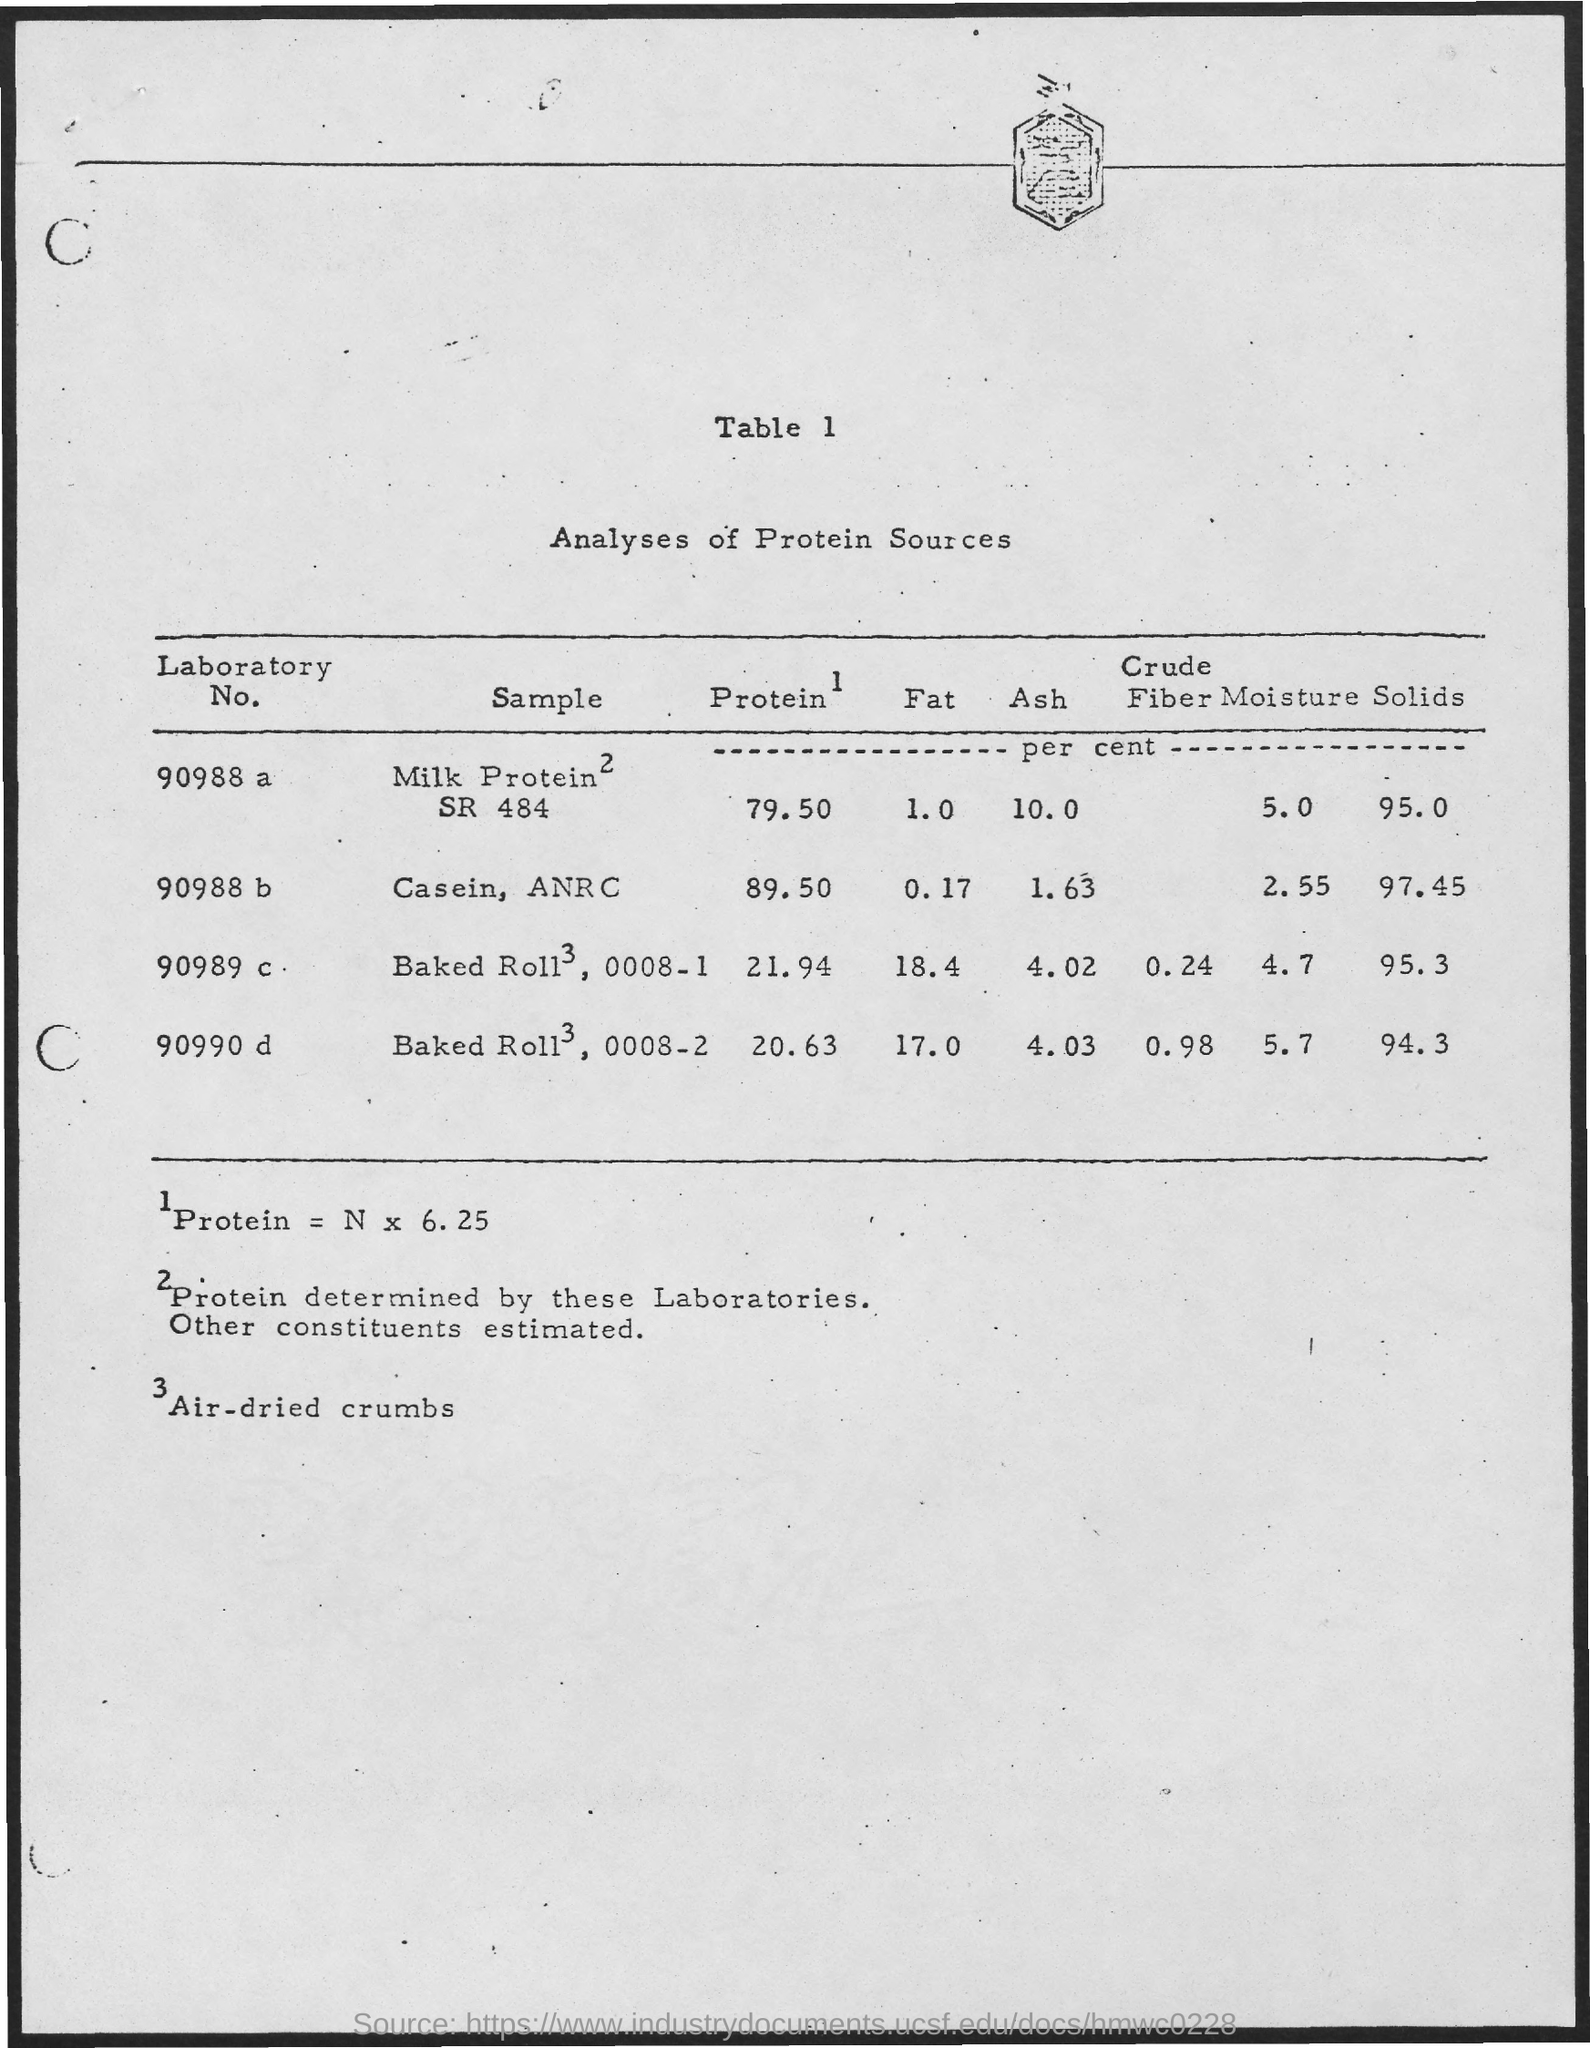Give some essential details in this illustration. The sample for Laboratory No. 90988 b is casein from the Agriculture and Natural Resources Center (ANRC). The Fat content for Laboratory No. 90988 is 1.0... The protein for Laboratory No. 90988 b is 89.50%. The protein for Laboratory No. 90988 is 79.50. The sample numbered Laboratory No. 90988 is milk protein S484. 